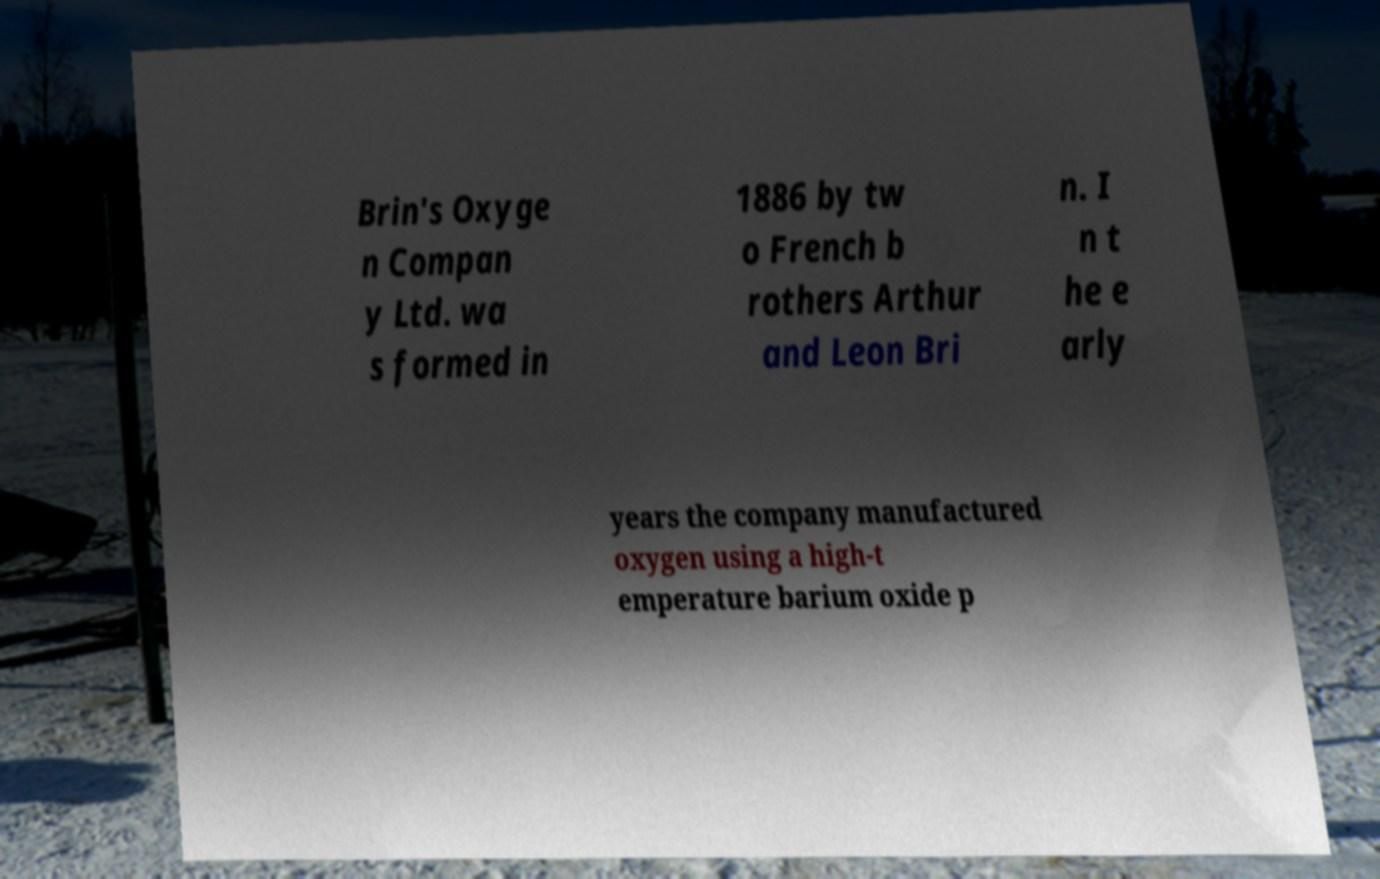I need the written content from this picture converted into text. Can you do that? Brin's Oxyge n Compan y Ltd. wa s formed in 1886 by tw o French b rothers Arthur and Leon Bri n. I n t he e arly years the company manufactured oxygen using a high-t emperature barium oxide p 